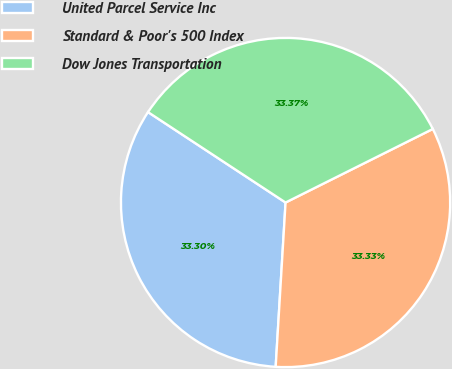<chart> <loc_0><loc_0><loc_500><loc_500><pie_chart><fcel>United Parcel Service Inc<fcel>Standard & Poor's 500 Index<fcel>Dow Jones Transportation<nl><fcel>33.3%<fcel>33.33%<fcel>33.37%<nl></chart> 